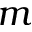<formula> <loc_0><loc_0><loc_500><loc_500>m</formula> 